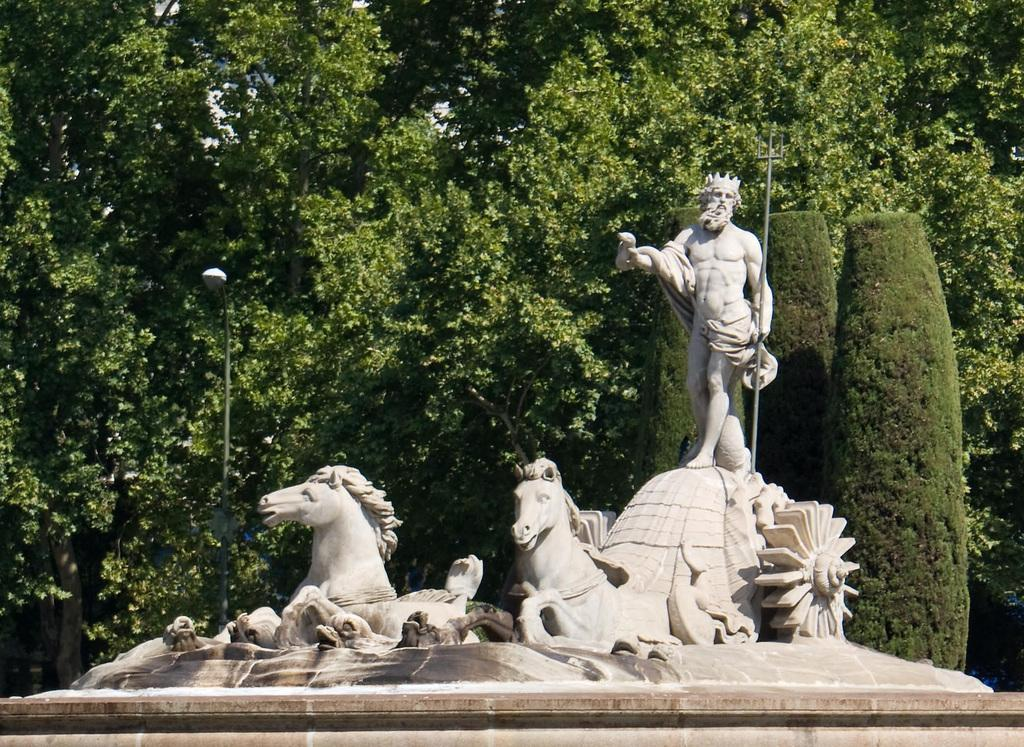What is the main subject of the image? There is a sculpture in the image. What can be seen behind the sculpture? There is a group of trees visible on the backside of the sculpture. What other object is present in the image? There is a street pole in the image. How many yaks can be seen interacting with the sculpture in the image? There are no yaks present in the image. What is the sculpture's primary use in the image? The image does not provide information about the sculpture's primary use. 